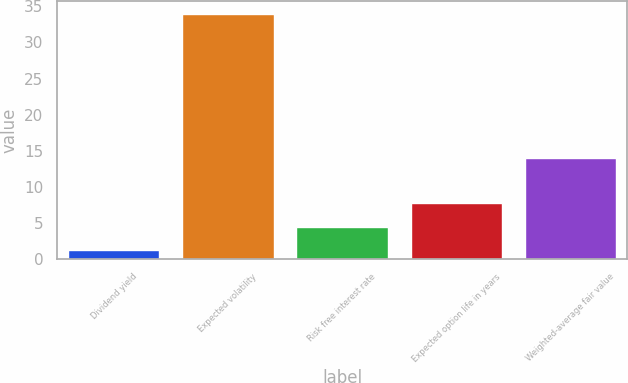Convert chart. <chart><loc_0><loc_0><loc_500><loc_500><bar_chart><fcel>Dividend yield<fcel>Expected volatility<fcel>Risk free interest rate<fcel>Expected option life in years<fcel>Weighted-average fair value<nl><fcel>1.2<fcel>34<fcel>4.48<fcel>7.76<fcel>13.92<nl></chart> 